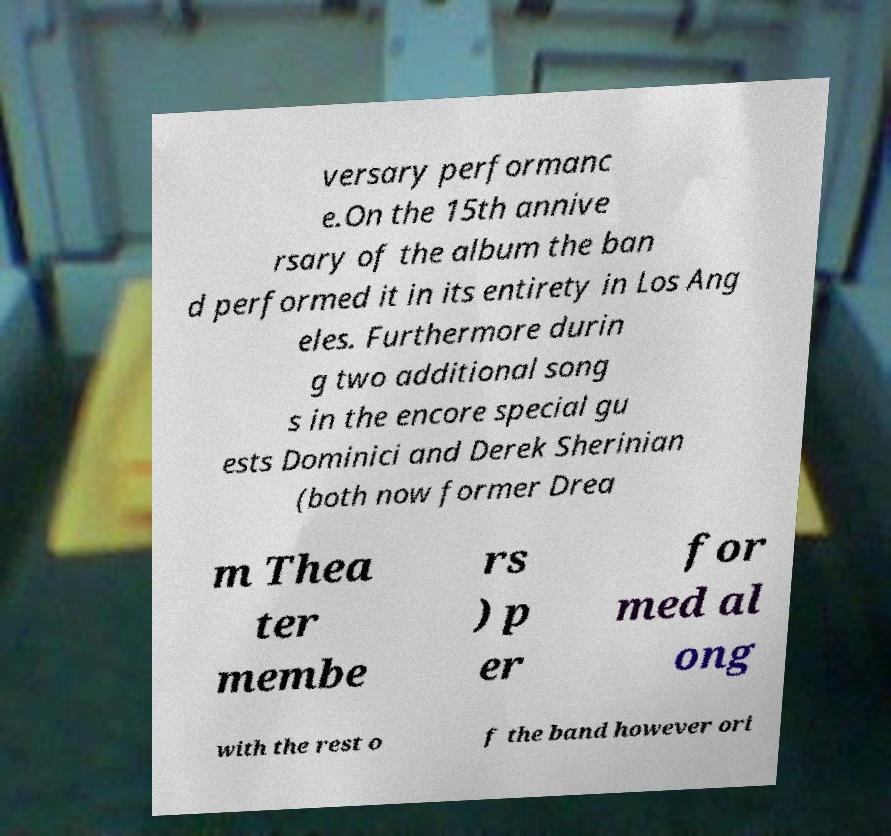Can you accurately transcribe the text from the provided image for me? versary performanc e.On the 15th annive rsary of the album the ban d performed it in its entirety in Los Ang eles. Furthermore durin g two additional song s in the encore special gu ests Dominici and Derek Sherinian (both now former Drea m Thea ter membe rs ) p er for med al ong with the rest o f the band however ori 